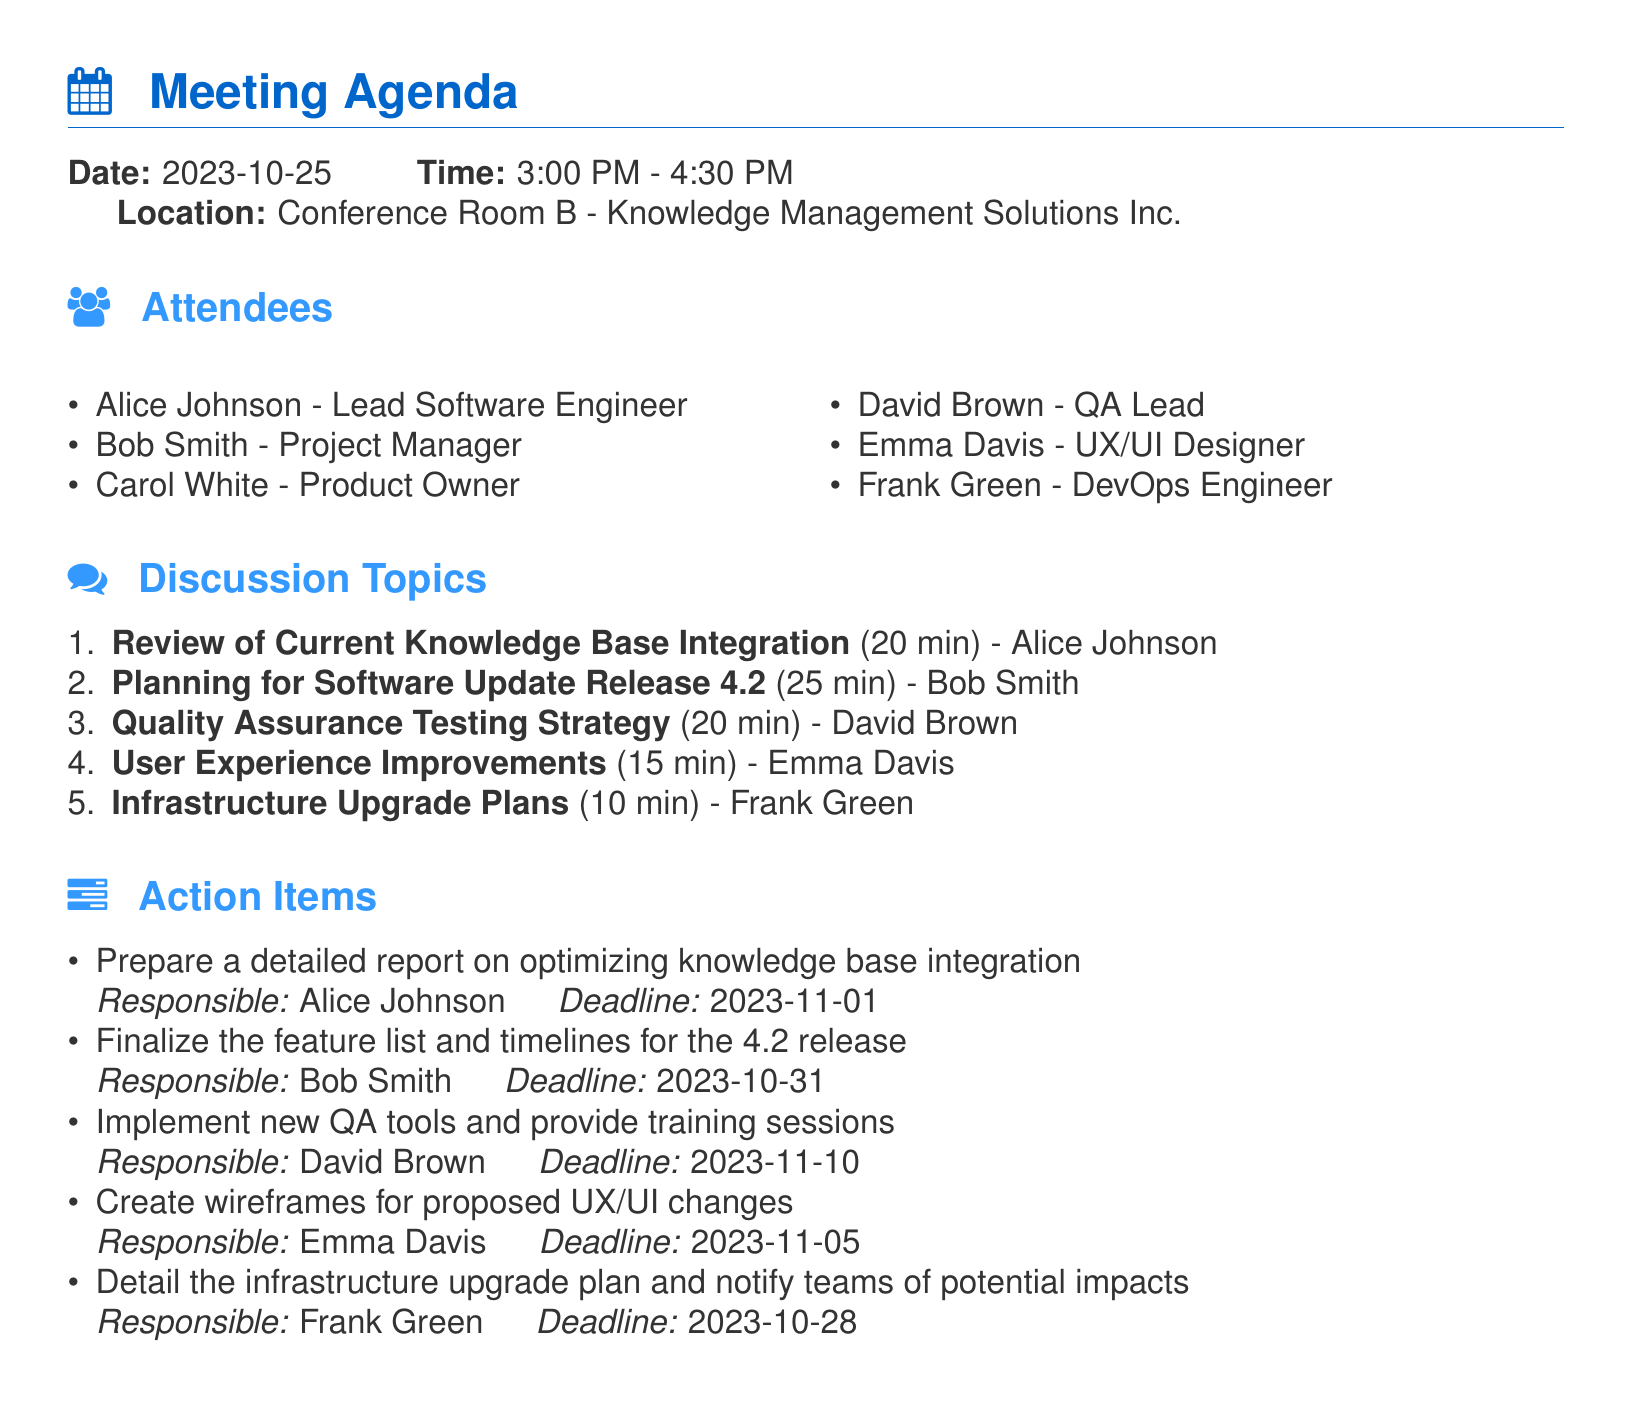What is the date of the meeting? The date listed in the document is when the meeting is scheduled to take place.
Answer: 2023-10-25 What is the duration of the meeting? The meeting starts at 3:00 PM and ends at 4:30 PM, which indicates its total runtime.
Answer: 1 hour 30 minutes Who is responsible for the infrastructure upgrade plan? This person is assigned to detail the plans related to infrastructure upgrades in the action items section.
Answer: Frank Green How many discussion topics are listed? The number of discussion topics can be counted in the enumeration under the discussion topics section.
Answer: 5 What is the deadline for creating wireframes for proposed UX/UI changes? The action items section specifies the due date for this task.
Answer: 2023-11-05 What is the total time allotted for reviewing the knowledge base integration? The time mentioned next to the first discussion topic indicates how long is allocated for it.
Answer: 20 min What is the location of the meeting? The document lists where the meeting will be held.
Answer: Conference Room B Which attendee is the Product Owner? The document lists the attendees along with their titles, one of which is the Product Owner.
Answer: Carol White 